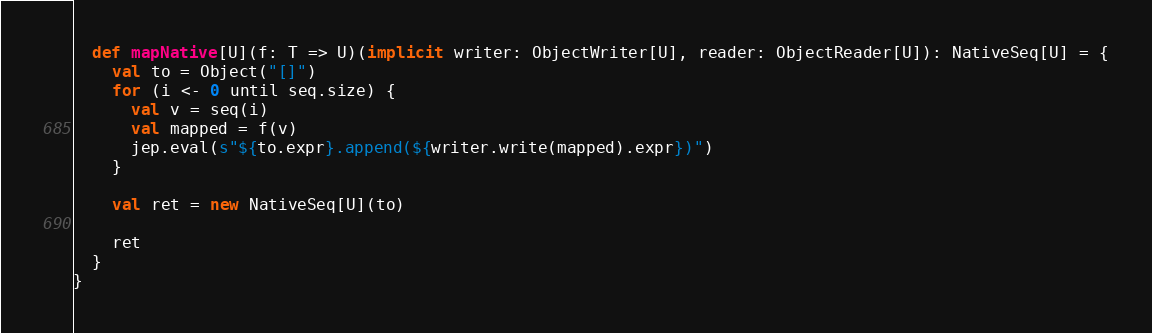Convert code to text. <code><loc_0><loc_0><loc_500><loc_500><_Scala_>  def mapNative[U](f: T => U)(implicit writer: ObjectWriter[U], reader: ObjectReader[U]): NativeSeq[U] = {
    val to = Object("[]")
    for (i <- 0 until seq.size) {
      val v = seq(i)
      val mapped = f(v)
      jep.eval(s"${to.expr}.append(${writer.write(mapped).expr})")
    }

    val ret = new NativeSeq[U](to)

    ret
  }
}
</code> 